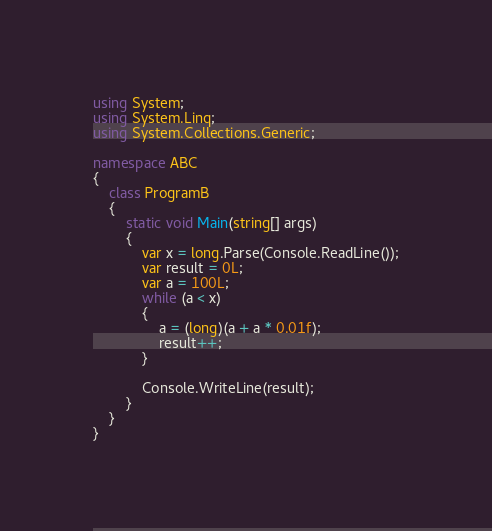<code> <loc_0><loc_0><loc_500><loc_500><_C#_>using System;
using System.Linq;
using System.Collections.Generic;

namespace ABC
{
    class ProgramB
    {
        static void Main(string[] args)
        {
            var x = long.Parse(Console.ReadLine());
            var result = 0L;
            var a = 100L;
            while (a < x)
            {
                a = (long)(a + a * 0.01f);
                result++;
            }

            Console.WriteLine(result);
        }
    }
}
</code> 